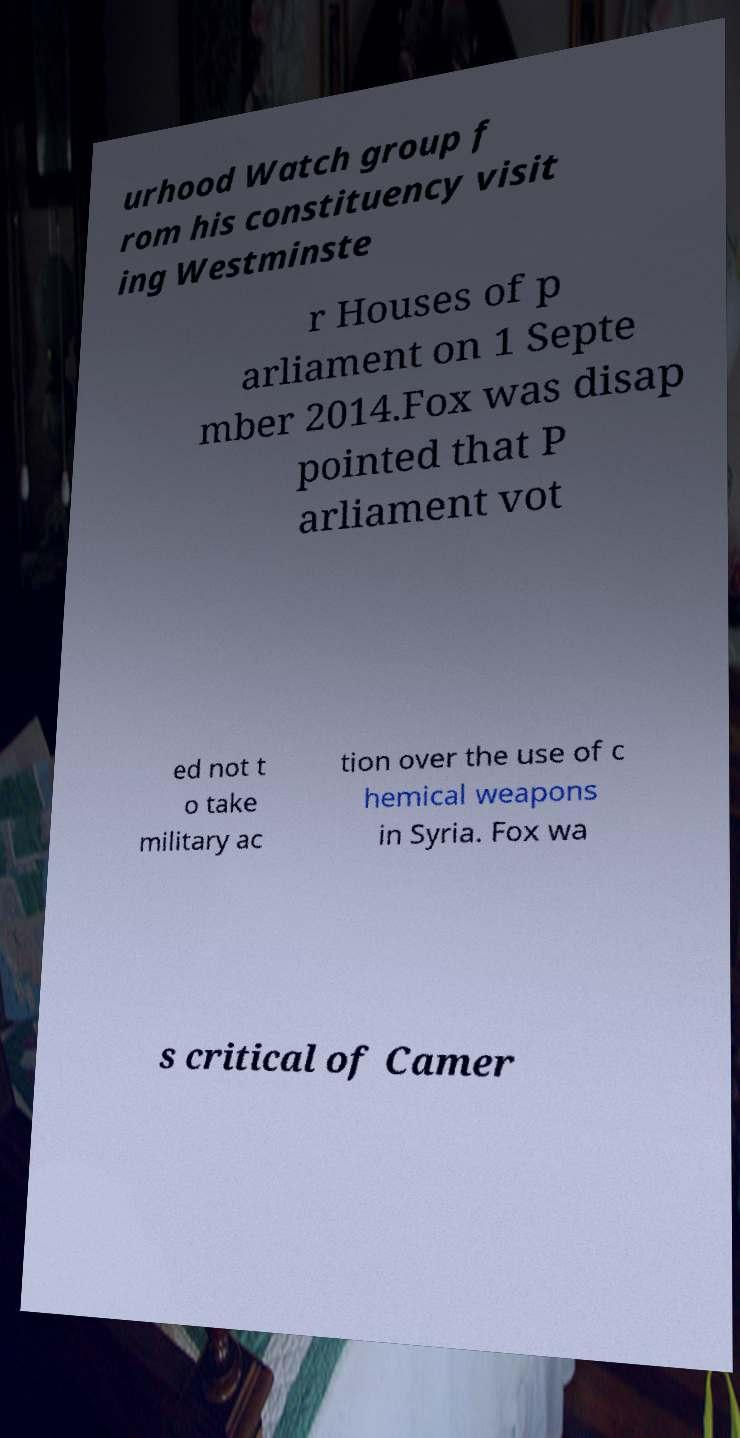Please identify and transcribe the text found in this image. urhood Watch group f rom his constituency visit ing Westminste r Houses of p arliament on 1 Septe mber 2014.Fox was disap pointed that P arliament vot ed not t o take military ac tion over the use of c hemical weapons in Syria. Fox wa s critical of Camer 